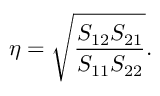Convert formula to latex. <formula><loc_0><loc_0><loc_500><loc_500>\eta = \sqrt { \frac { S _ { 1 2 } S _ { 2 1 } } { S _ { 1 1 } S _ { 2 2 } } } .</formula> 